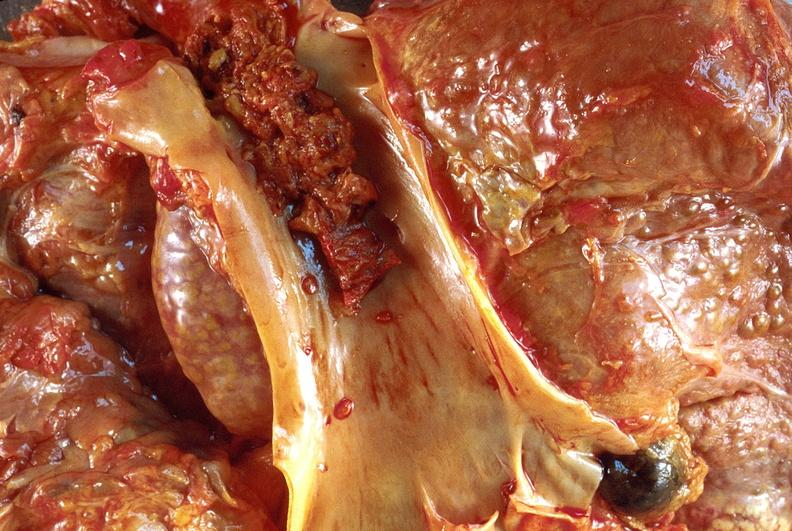s this image present?
Answer the question using a single word or phrase. No 